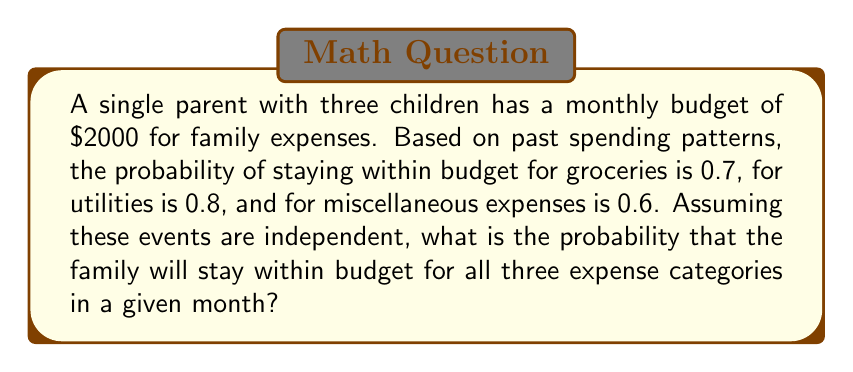Can you answer this question? To solve this problem, we need to follow these steps:

1. Identify the independent events:
   - Staying within budget for groceries (probability = 0.7)
   - Staying within budget for utilities (probability = 0.8)
   - Staying within budget for miscellaneous expenses (probability = 0.6)

2. Calculate the probability of all events occurring simultaneously:
   - For independent events, we multiply their individual probabilities.
   - Let's call the probability of staying within budget for all categories P(All).

   $$P(All) = P(Groceries) \times P(Utilities) \times P(Miscellaneous)$$
   $$P(All) = 0.7 \times 0.8 \times 0.6$$

3. Perform the calculation:
   $$P(All) = 0.7 \times 0.8 \times 0.6 = 0.336$$

Therefore, the probability of staying within budget for all three expense categories in a given month is 0.336 or 33.6%.
Answer: 0.336 